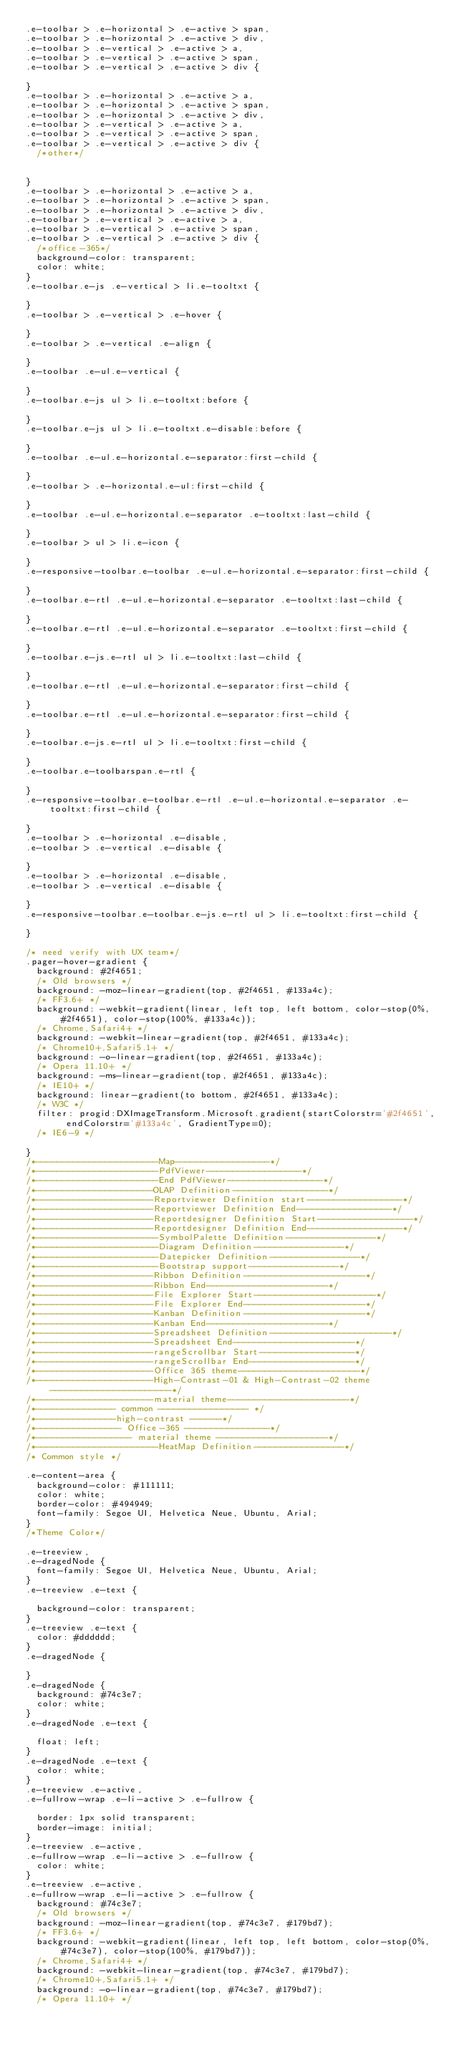Convert code to text. <code><loc_0><loc_0><loc_500><loc_500><_CSS_>.e-toolbar > .e-horizontal > .e-active > span,
.e-toolbar > .e-horizontal > .e-active > div,
.e-toolbar > .e-vertical > .e-active > a,
.e-toolbar > .e-vertical > .e-active > span,
.e-toolbar > .e-vertical > .e-active > div {
  
}
.e-toolbar > .e-horizontal > .e-active > a,
.e-toolbar > .e-horizontal > .e-active > span,
.e-toolbar > .e-horizontal > .e-active > div,
.e-toolbar > .e-vertical > .e-active > a,
.e-toolbar > .e-vertical > .e-active > span,
.e-toolbar > .e-vertical > .e-active > div {
  /*other*/

  
}
.e-toolbar > .e-horizontal > .e-active > a,
.e-toolbar > .e-horizontal > .e-active > span,
.e-toolbar > .e-horizontal > .e-active > div,
.e-toolbar > .e-vertical > .e-active > a,
.e-toolbar > .e-vertical > .e-active > span,
.e-toolbar > .e-vertical > .e-active > div {
  /*office-365*/
  background-color: transparent;
  color: white;
}
.e-toolbar.e-js .e-vertical > li.e-tooltxt {
  
}
.e-toolbar > .e-vertical > .e-hover {
  
}
.e-toolbar > .e-vertical .e-align {
  
}
.e-toolbar .e-ul.e-vertical {
  
}
.e-toolbar.e-js ul > li.e-tooltxt:before {
  
}
.e-toolbar.e-js ul > li.e-tooltxt.e-disable:before {
  
}
.e-toolbar .e-ul.e-horizontal.e-separator:first-child {
  
}
.e-toolbar > .e-horizontal.e-ul:first-child {
  
}
.e-toolbar .e-ul.e-horizontal.e-separator .e-tooltxt:last-child {
  
}
.e-toolbar > ul > li.e-icon {
  
}
.e-responsive-toolbar.e-toolbar .e-ul.e-horizontal.e-separator:first-child {
  
}
.e-toolbar.e-rtl .e-ul.e-horizontal.e-separator .e-tooltxt:last-child {
  
}
.e-toolbar.e-rtl .e-ul.e-horizontal.e-separator .e-tooltxt:first-child {
  
}
.e-toolbar.e-js.e-rtl ul > li.e-tooltxt:last-child {
  
}
.e-toolbar.e-rtl .e-ul.e-horizontal.e-separator:first-child {
  
}
.e-toolbar.e-rtl .e-ul.e-horizontal.e-separator:first-child {
  
}
.e-toolbar.e-js.e-rtl ul > li.e-tooltxt:first-child {
  
}
.e-toolbar.e-toolbarspan.e-rtl {
  
}
.e-responsive-toolbar.e-toolbar.e-rtl .e-ul.e-horizontal.e-separator .e-tooltxt:first-child {
  
}
.e-toolbar > .e-horizontal .e-disable,
.e-toolbar > .e-vertical .e-disable {
  
}
.e-toolbar > .e-horizontal .e-disable,
.e-toolbar > .e-vertical .e-disable {
  
}
.e-responsive-toolbar.e-toolbar.e-js.e-rtl ul > li.e-tooltxt:first-child {
  
}

/* need verify with UX team*/
.pager-hover-gradient {
  background: #2f4651;
  /* Old browsers */
  background: -moz-linear-gradient(top, #2f4651, #133a4c);
  /* FF3.6+ */
  background: -webkit-gradient(linear, left top, left bottom, color-stop(0%, #2f4651), color-stop(100%, #133a4c));
  /* Chrome,Safari4+ */
  background: -webkit-linear-gradient(top, #2f4651, #133a4c);
  /* Chrome10+,Safari5.1+ */
  background: -o-linear-gradient(top, #2f4651, #133a4c);
  /* Opera 11.10+ */
  background: -ms-linear-gradient(top, #2f4651, #133a4c);
  /* IE10+ */
  background: linear-gradient(to bottom, #2f4651, #133a4c);
  /* W3C */
  filter: progid:DXImageTransform.Microsoft.gradient(startColorstr='#2f4651', endColorstr='#133a4c', GradientType=0);
  /* IE6-9 */

}
/*-----------------------Map------------------*/
/*-----------------------PdfViewer------------------*/
/*-----------------------End PdfViewer------------------*/
/*----------------------OLAP Definition------------------*/
/*----------------------Reportviewer Definition start------------------*/
/*----------------------Reportviewer Definition End------------------*/
/*----------------------Reportdesigner Definition Start------------------*/
/*----------------------Reportdesigner Definition End------------------*/
/*-----------------------SymbolPalette Definition-----------------*/
/*-----------------------Diagram Definition-----------------*/
/*-----------------------Datepicker Definition-----------------*/
/*-----------------------Bootstrap support-----------------*/
/*----------------------Ribbon Definition-----------------------*/
/*----------------------Ribbon End-----------------------*/
/*----------------------File Explorer Start-----------------------*/
/*----------------------File Explorer End-----------------------*/
/*----------------------Kanban Definition-----------------------*/
/*----------------------Kanban End-----------------------*/
/*----------------------Spreadsheet Definition-----------------------*/
/*----------------------Spreadsheet End-----------------------*/
/*----------------------rangeScrollbar Start------------------*/
/*----------------------rangeScrollbar End--------------------*/
/*----------------------Office 365 theme-----------------------*/
/*----------------------High-Contrast-01 & High-Contrast-02 theme-----------------------*/
/*----------------------material theme-----------------------*/
/*--------------- common ----------------- */
/*---------------high-contrast ------*/
/*---------------- Office-365 ----------------*/
/*------------------ material theme ---------------------*/
/*-----------------------HeatMap Definition-----------------*/
/* Common style */

.e-content-area {
  background-color: #111111;
  color: white;
  border-color: #494949;
  font-family: Segoe UI, Helvetica Neue, Ubuntu, Arial;
}
/*Theme Color*/

.e-treeview,
.e-dragedNode {
  font-family: Segoe UI, Helvetica Neue, Ubuntu, Arial;
}
.e-treeview .e-text {
  
  background-color: transparent;
}
.e-treeview .e-text {
  color: #dddddd;
}
.e-dragedNode {
  
}
.e-dragedNode {
  background: #74c3e7;
  color: white;
}
.e-dragedNode .e-text {
  
  float: left;
}
.e-dragedNode .e-text {
  color: white;
}
.e-treeview .e-active,
.e-fullrow-wrap .e-li-active > .e-fullrow {
  
  border: 1px solid transparent;
  border-image: initial;
}
.e-treeview .e-active,
.e-fullrow-wrap .e-li-active > .e-fullrow {
  color: white;
}
.e-treeview .e-active,
.e-fullrow-wrap .e-li-active > .e-fullrow {
  background: #74c3e7;
  /* Old browsers */
  background: -moz-linear-gradient(top, #74c3e7, #179bd7);
  /* FF3.6+ */
  background: -webkit-gradient(linear, left top, left bottom, color-stop(0%, #74c3e7), color-stop(100%, #179bd7));
  /* Chrome,Safari4+ */
  background: -webkit-linear-gradient(top, #74c3e7, #179bd7);
  /* Chrome10+,Safari5.1+ */
  background: -o-linear-gradient(top, #74c3e7, #179bd7);
  /* Opera 11.10+ */</code> 